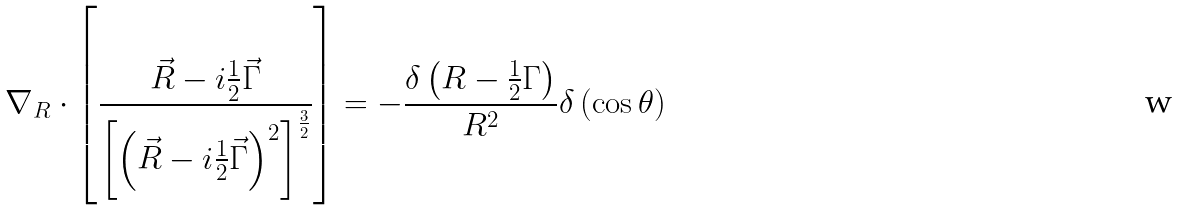<formula> <loc_0><loc_0><loc_500><loc_500>\nabla _ { R } \cdot \left [ \frac { \vec { R } - i \frac { 1 } { 2 } \vec { \Gamma } } { \left [ \left ( \vec { R } - i \frac { 1 } { 2 } \vec { \Gamma } \right ) ^ { 2 } \right ] ^ { \frac { 3 } { 2 } } } \right ] = - \frac { \delta \left ( R - \frac { 1 } { 2 } \Gamma \right ) } { R ^ { 2 } } \delta \left ( \cos \theta \right )</formula> 